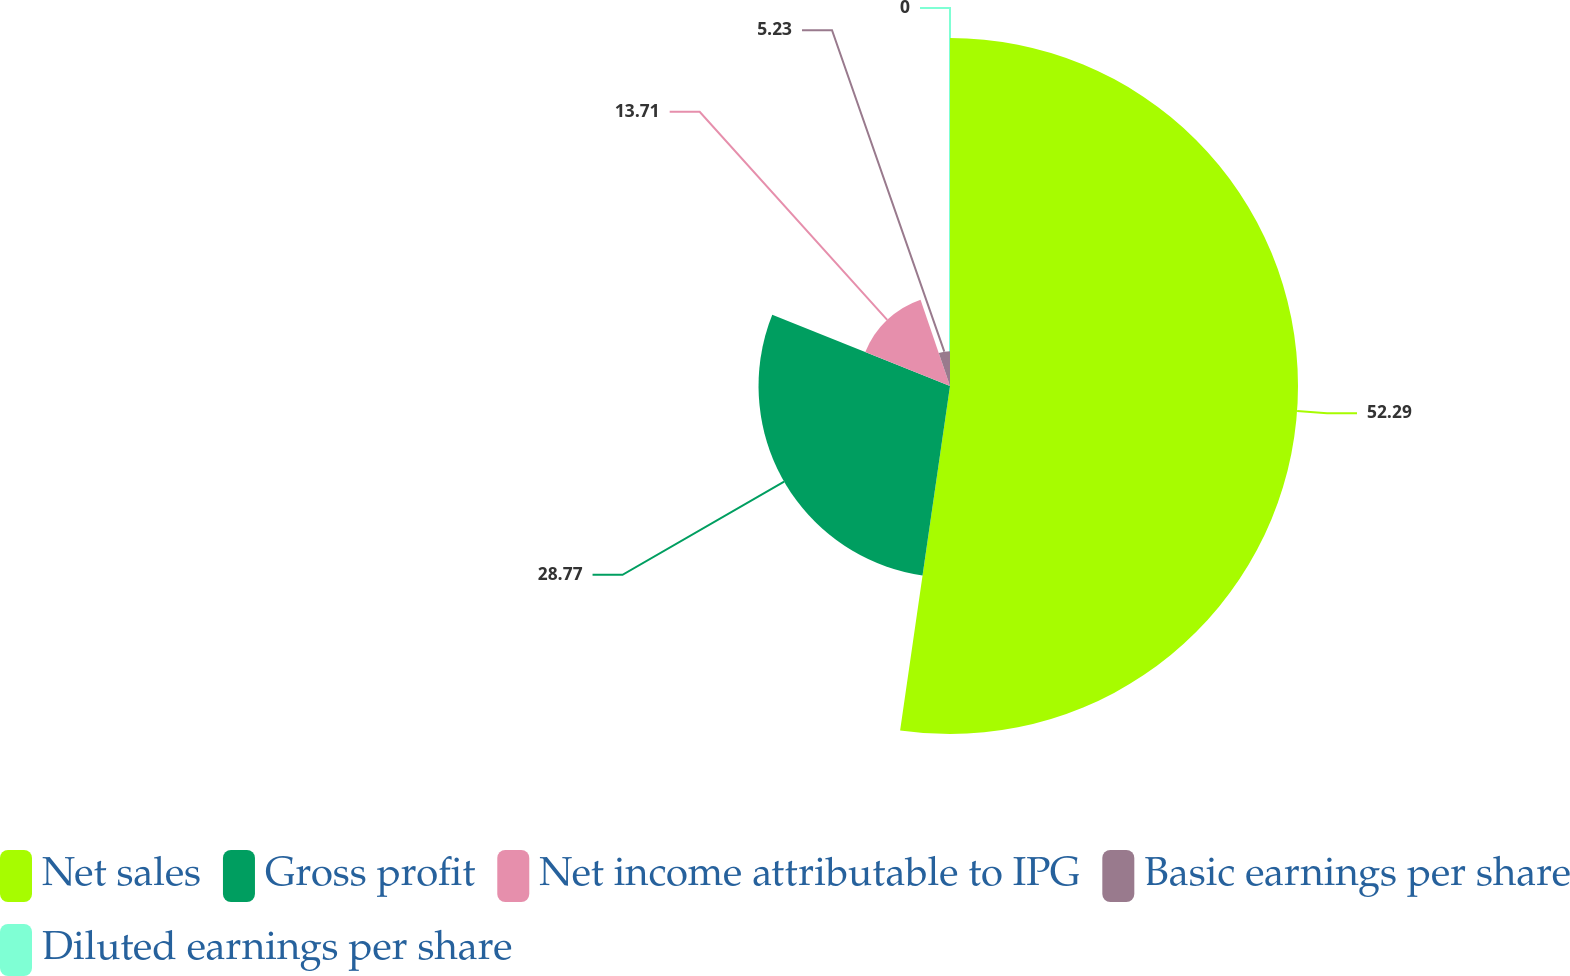Convert chart to OTSL. <chart><loc_0><loc_0><loc_500><loc_500><pie_chart><fcel>Net sales<fcel>Gross profit<fcel>Net income attributable to IPG<fcel>Basic earnings per share<fcel>Diluted earnings per share<nl><fcel>52.29%<fcel>28.77%<fcel>13.71%<fcel>5.23%<fcel>0.0%<nl></chart> 